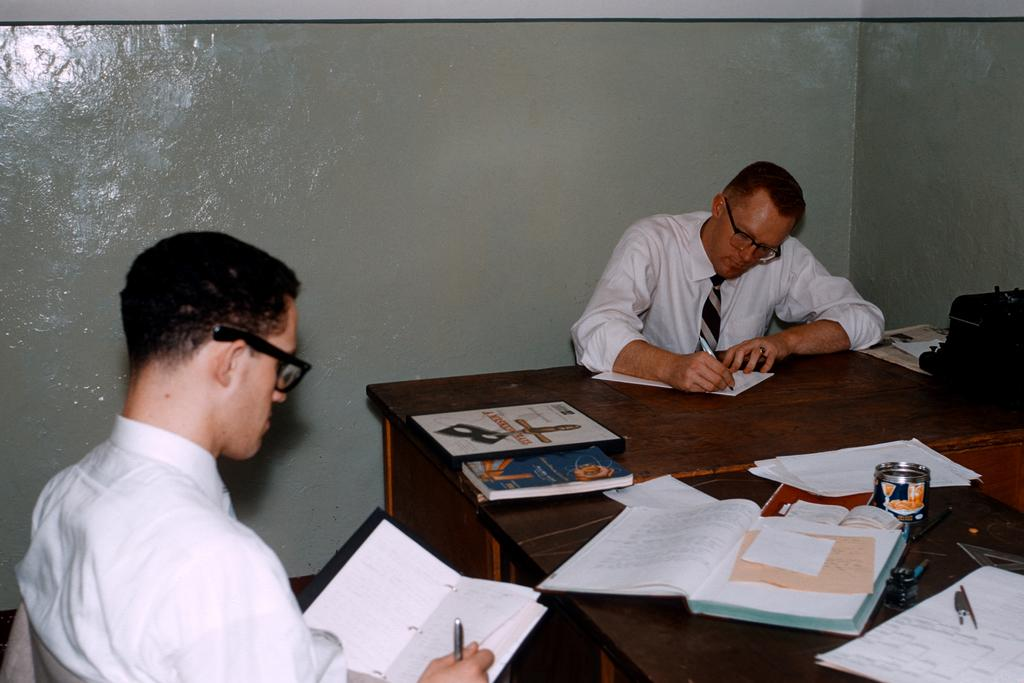How many people are sitting in chairs in the image? There are two people sitting in chairs in the image. What is on the table in the image? There are books, a tin, and a pen on the table in the image. What might the men be doing while sitting in the chairs? They might be reading or working, given the presence of books and a pen on the table. Where is the baby playing with the zipper in the image? There is no baby or zipper present in the image. What type of power is being generated by the men in the image? There is no indication of power generation in the image; the men are likely engaged in reading or working. 